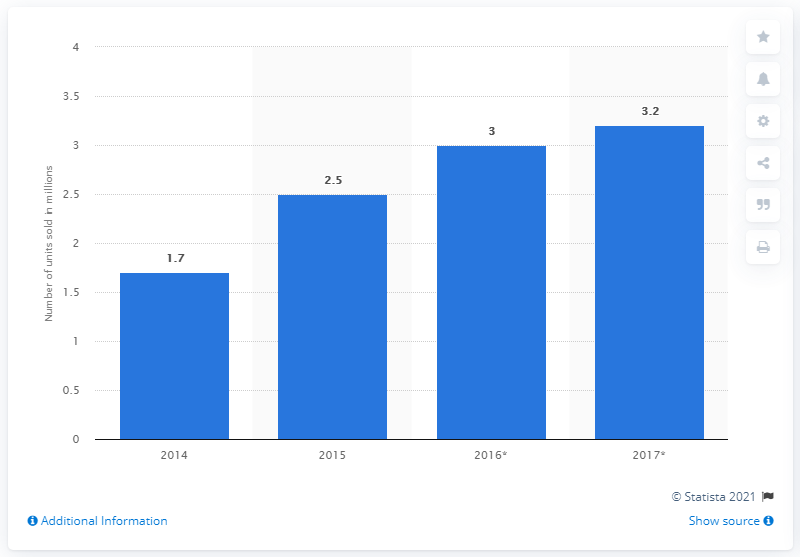Identify some key points in this picture. In 2015, 3.2 million action cams were sold in Western Europe. In 2015, a total of 2.5 million action cams were sold in Western Europe. 